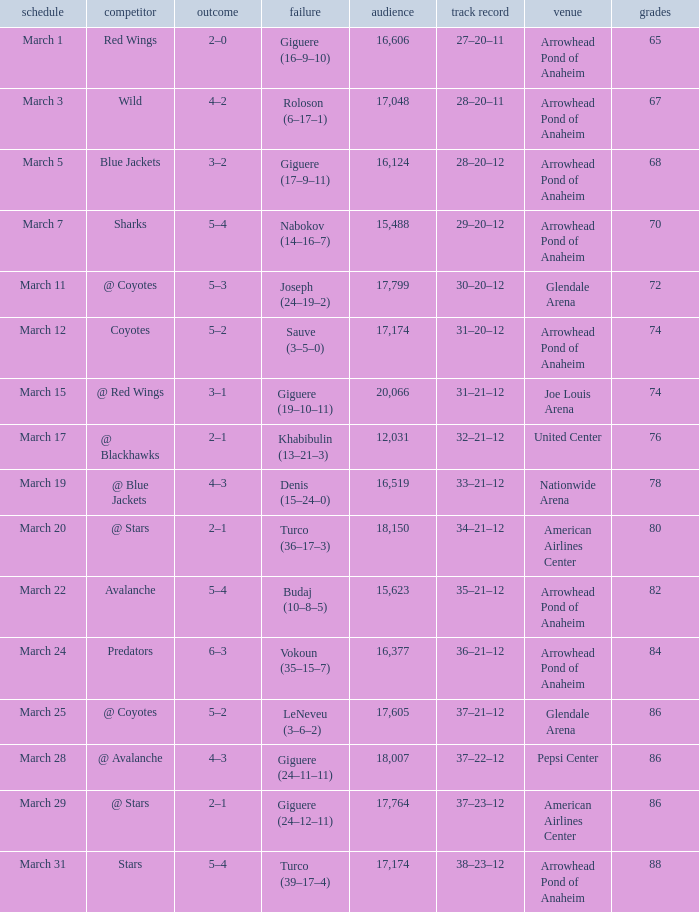What is the Score of the game on March 19? 4–3. 